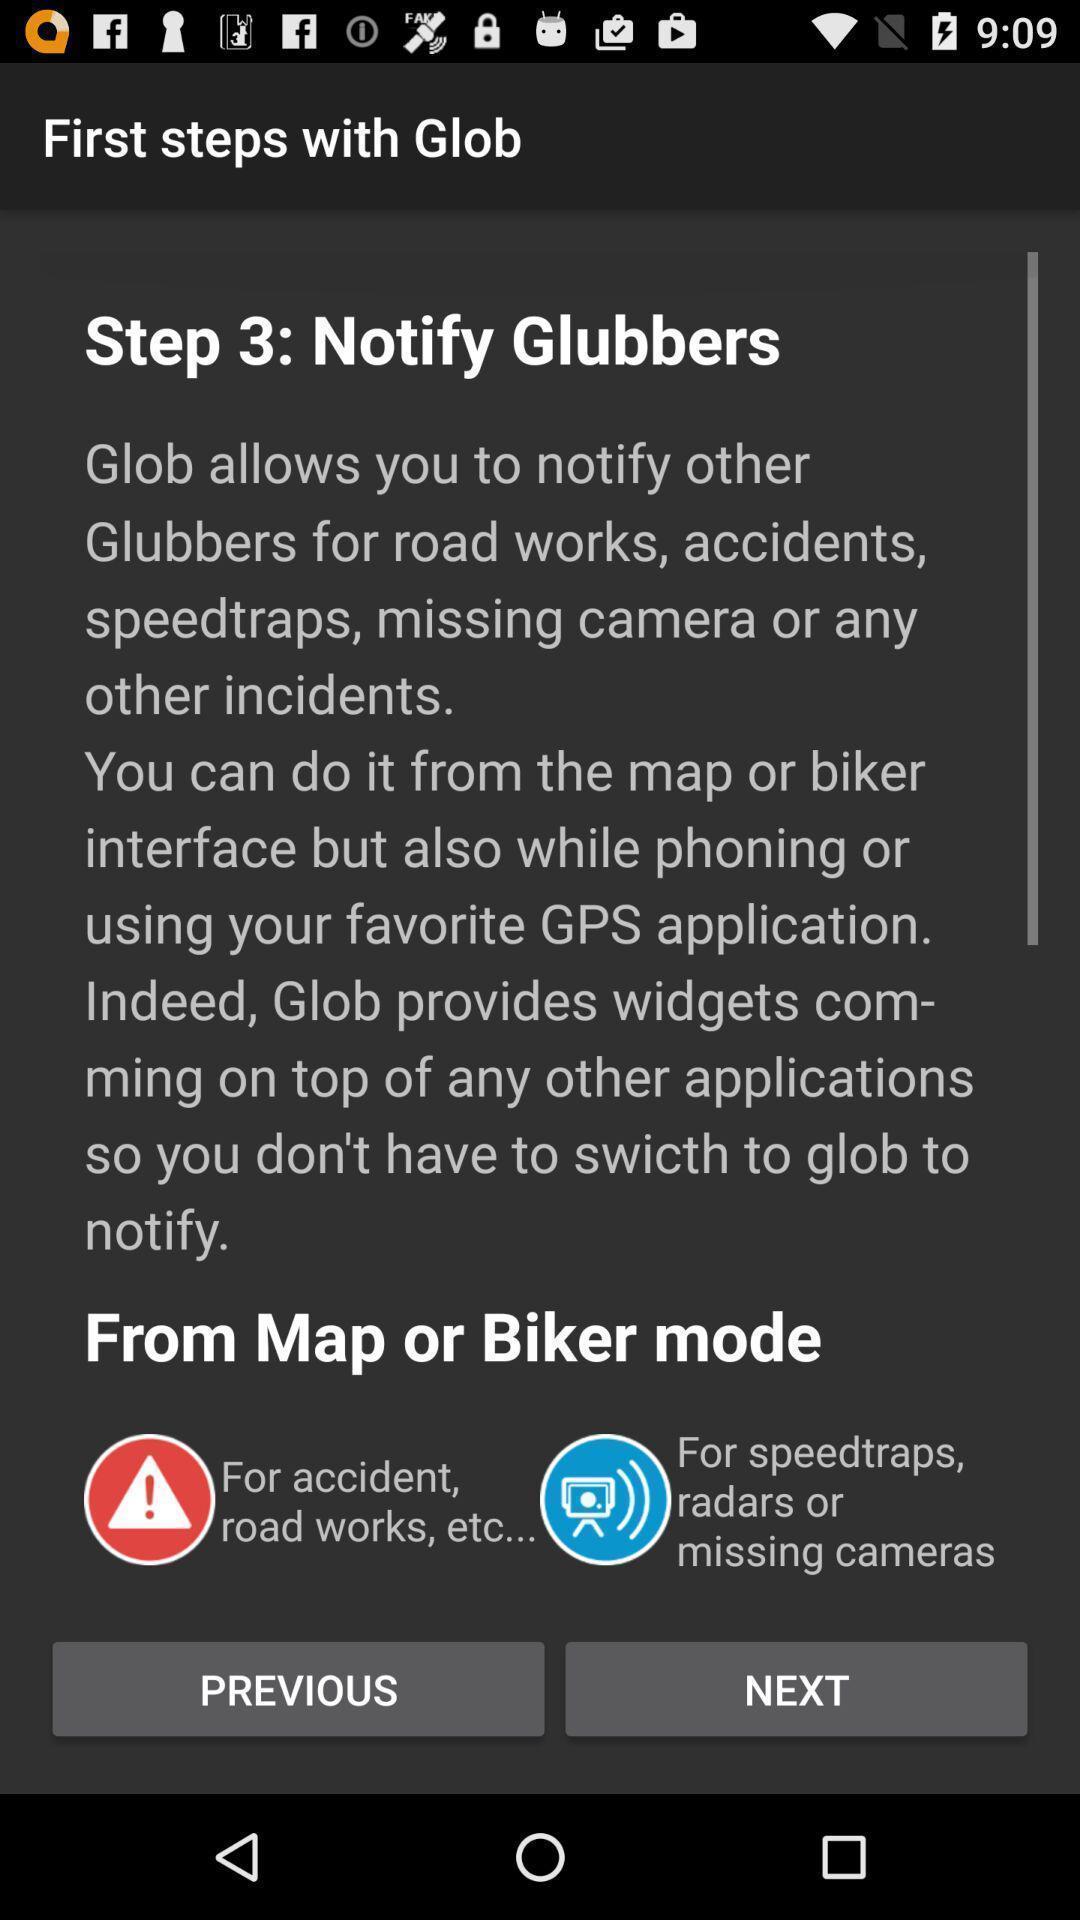Explain what's happening in this screen capture. Page shows the notification options for map or biker mode. 